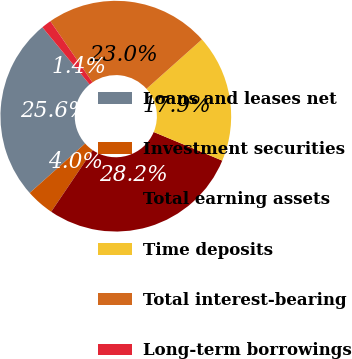Convert chart. <chart><loc_0><loc_0><loc_500><loc_500><pie_chart><fcel>Loans and leases net<fcel>Investment securities<fcel>Total earning assets<fcel>Time deposits<fcel>Total interest-bearing<fcel>Long-term borrowings<nl><fcel>25.6%<fcel>3.95%<fcel>28.17%<fcel>17.88%<fcel>23.02%<fcel>1.38%<nl></chart> 